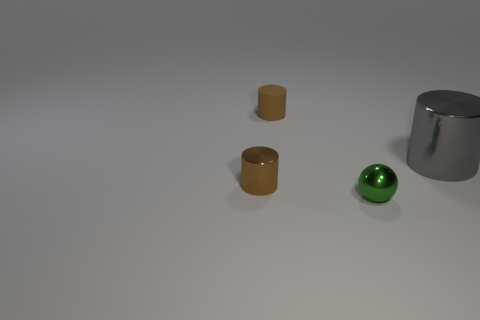What is the material of the tiny thing that is the same color as the matte cylinder?
Your response must be concise. Metal. There is a tiny matte object; does it have the same color as the metallic cylinder in front of the large cylinder?
Keep it short and to the point. Yes. Are there any other tiny objects that have the same color as the matte thing?
Your answer should be very brief. Yes. What number of cyan objects are cylinders or metal cylinders?
Keep it short and to the point. 0. Is the number of brown matte cylinders that are right of the brown rubber thing the same as the number of small blue rubber balls?
Offer a terse response. Yes. How big is the shiny object that is to the right of the green object?
Your answer should be compact. Large. What number of brown metallic objects are the same shape as the big gray object?
Provide a short and direct response. 1. There is a thing that is behind the green thing and in front of the large gray cylinder; what is its material?
Offer a terse response. Metal. Do the gray thing and the ball have the same material?
Offer a terse response. Yes. What number of blue objects are there?
Keep it short and to the point. 0. 